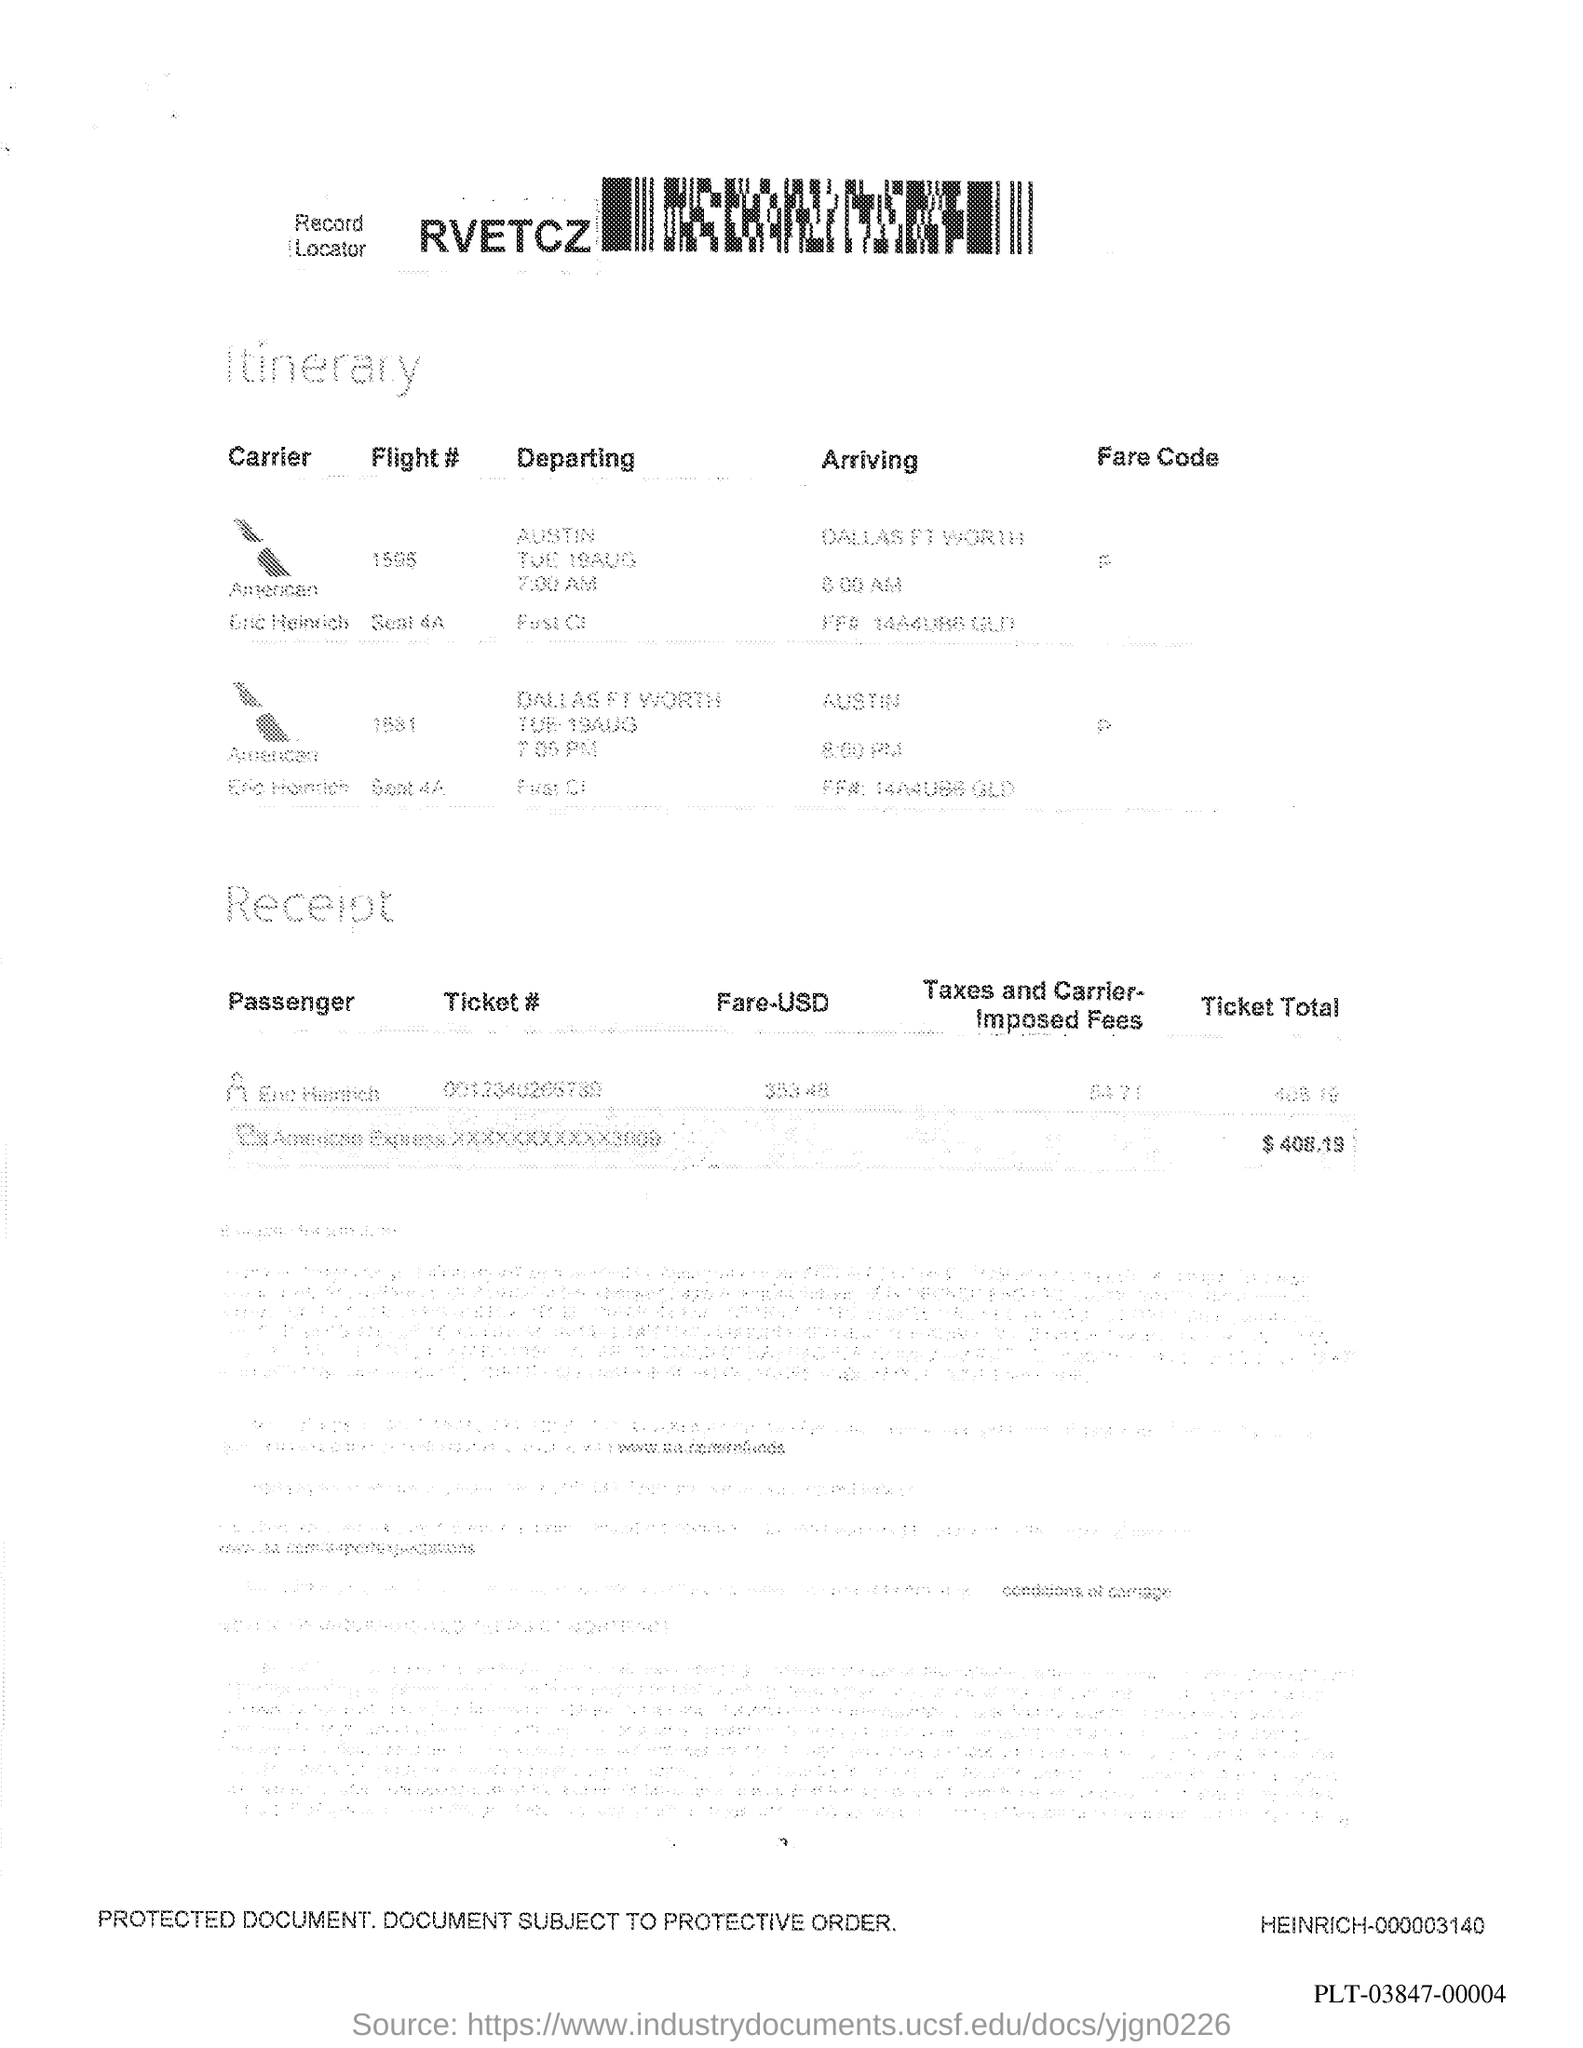Specify some key components in this picture. The ticket total is $408.19. The flight number 1595 is departing from Austin. The document is about an itinerary. The code that follows the Record Locator is RVETCZ. 